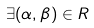<formula> <loc_0><loc_0><loc_500><loc_500>\exists ( \alpha , \beta ) \in R</formula> 